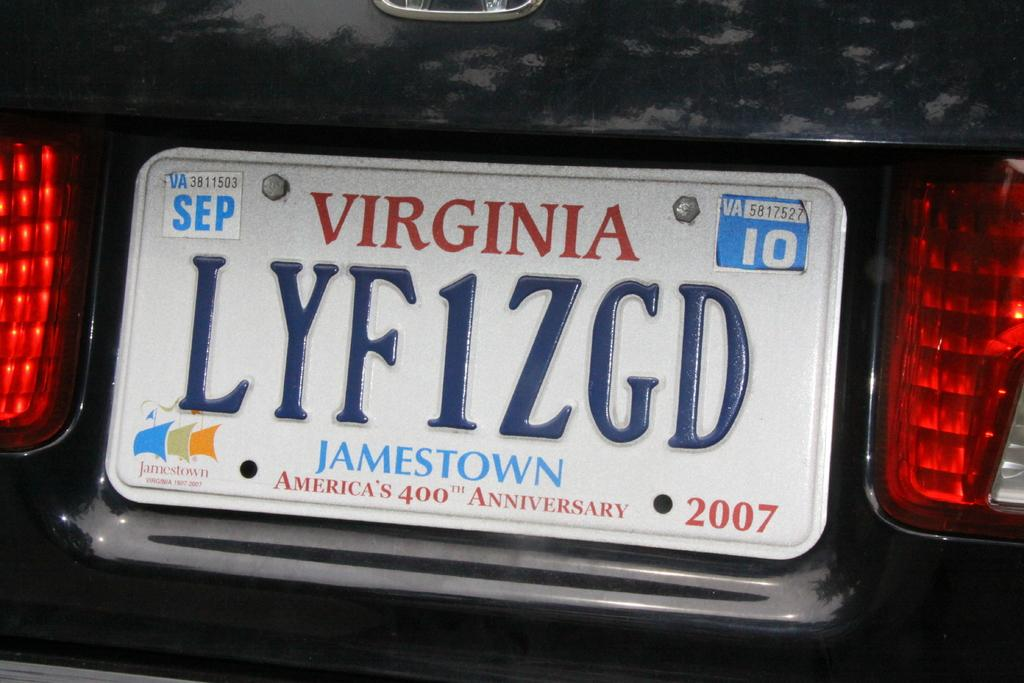<image>
Give a short and clear explanation of the subsequent image. White Virginia license plate which says LYF1ZGD on it. 